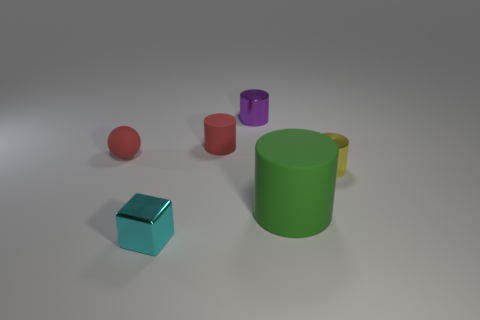Subtract 1 cylinders. How many cylinders are left? 3 Add 1 small red things. How many objects exist? 7 Subtract all cylinders. How many objects are left? 2 Add 1 small shiny things. How many small shiny things are left? 4 Add 1 small blue shiny blocks. How many small blue shiny blocks exist? 1 Subtract 1 yellow cylinders. How many objects are left? 5 Subtract all small cylinders. Subtract all metal things. How many objects are left? 0 